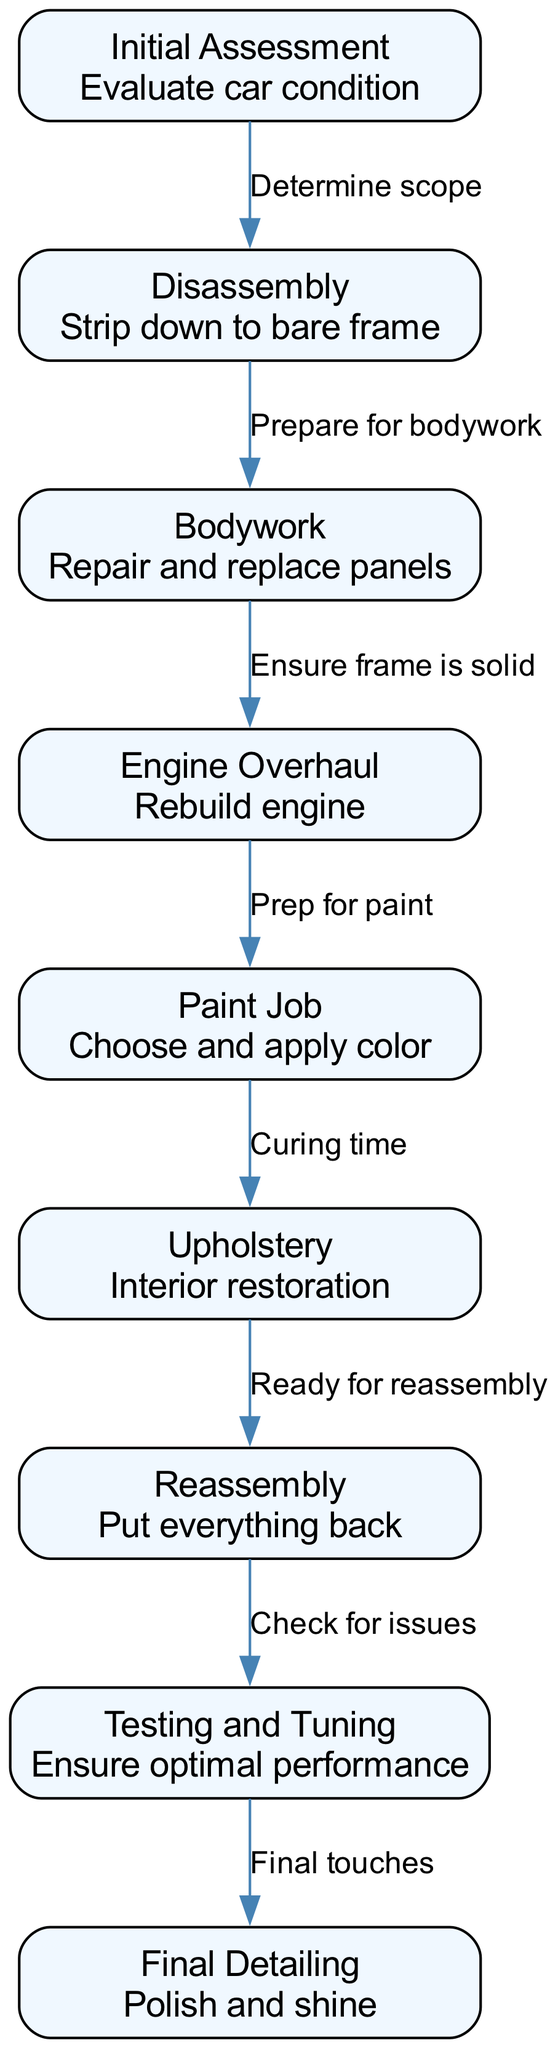What is the first step in the restoration process? The diagram shows that the first step is "Initial Assessment," where the car's condition is evaluated.
Answer: Initial Assessment How many nodes are in the diagram? By counting each distinct step in the restoration process, we see that there are 9 nodes (steps) highlighted in the diagram.
Answer: 9 Which step comes after "Disassembly"? According to the flow in the diagram, "Bodywork" follows "Disassembly" as the next step in the restoration process.
Answer: Bodywork What is the last step before "Final Detailing"? The step right before "Final Detailing" in the diagram is "Testing and Tuning," ensuring the car's optimal performance.
Answer: Testing and Tuning What relationship does "Engine Overhaul" have with "Paint Job"? The edge from "Engine Overhaul" to "Paint Job" indicates that "Prep for paint" follows the engine work, showcasing a sequential relationship.
Answer: Prep for paint How many edges are in the diagram? Each connection between steps is an edge, and by counting those, we identify there are 8 edges in total connecting the nodes.
Answer: 8 What comes after "Upholstery"? "Upholstery" leads to "Reassembly," indicating that reassembling the car occurs after the interior restoration step.
Answer: Reassembly What must be done before "Engine Overhaul"? The diagram indicates that before conducting the "Engine Overhaul," one must complete "Bodywork" to ensure the frame is solid.
Answer: Bodywork Which step includes ensuring optimal performance? The step that involves checking for optimal performance is "Testing and Tuning," a crucial stage of the restoration process.
Answer: Testing and Tuning 